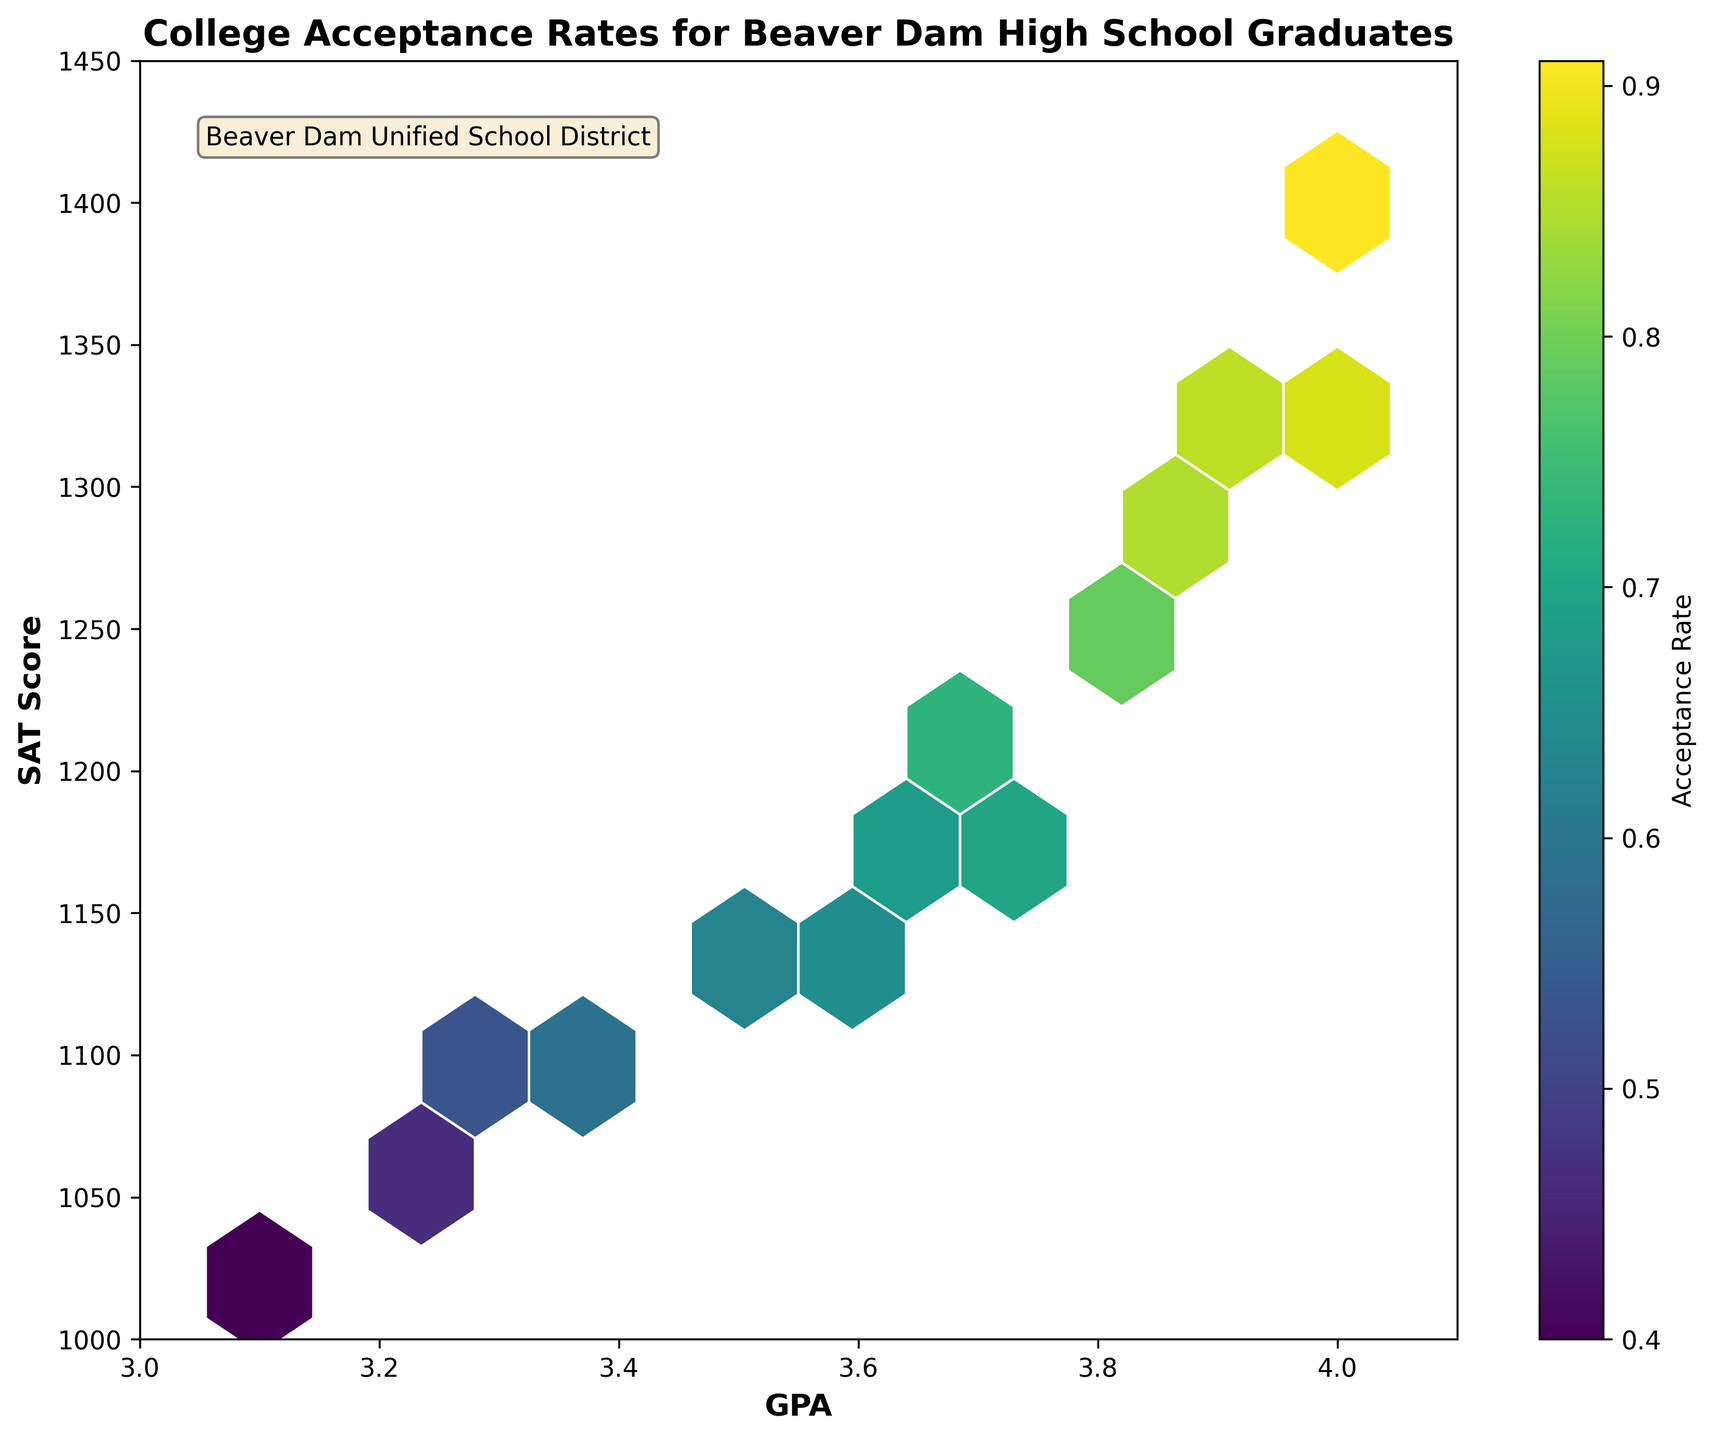What is the title of the plot? The title of the plot is written at the top and it summarizes what the plot is about.
Answer: College Acceptance Rates for Beaver Dam High School Graduates What range of GPA values is displayed on the x-axis? The x-axis shows GPA values, which are labeled clearly on the plot.
Answer: 3.0 to 4.1 What is the highest acceptance rate shown on the color bar? The color bar on the right side of the plot indicates the range of acceptance rates using color gradients.
Answer: 0.92 What does the color intensity in the hexagons represent? In a Hexbin plot, the color intensity of the hexagons represents the values of a third variable, which are specified by the color bar on the right side.
Answer: Acceptance Rate Which GPA and SAT Score combination seems to have the highest concentration of data points? By looking at the hexagon with the deepest color, we can identify where the highest concentration of data points lies.
Answer: Around a GPA of 3.7 and SAT Score of 1200 How does the acceptance rate generally change with an increase in GPA and SAT scores? Observing the general trend in the color gradient from lower-left to upper-right, we can infer the trend.
Answer: It generally increases Which range of SAT scores shows the most variety in acceptance rates for a GPA of 4.0? For a GPA of 4.0, by looking at the range of SAT scores and their corresponding color intensity, we can identify the range.
Answer: 1340 to 1400 Are there any GPA and SAT score combinations that show particularly low acceptance rates? By checking for hexagons with lighter colors, we can find these combinations.
Answer: 3.1 GPA and 1020 SAT score What can you say about the acceptance rate for students with a perfect GPA of 4.0? Examining the hexagons around a GPA of 4.0 and noting their color intensities, we can derive an insight.
Answer: It is generally high Does the plot provide any indication of a minimum acceptance rate threshold for the given data? Observing the color gradients from the color bar and noting the lightest color, we can determine the minimum acceptance rate shown.
Answer: Around 0.40 